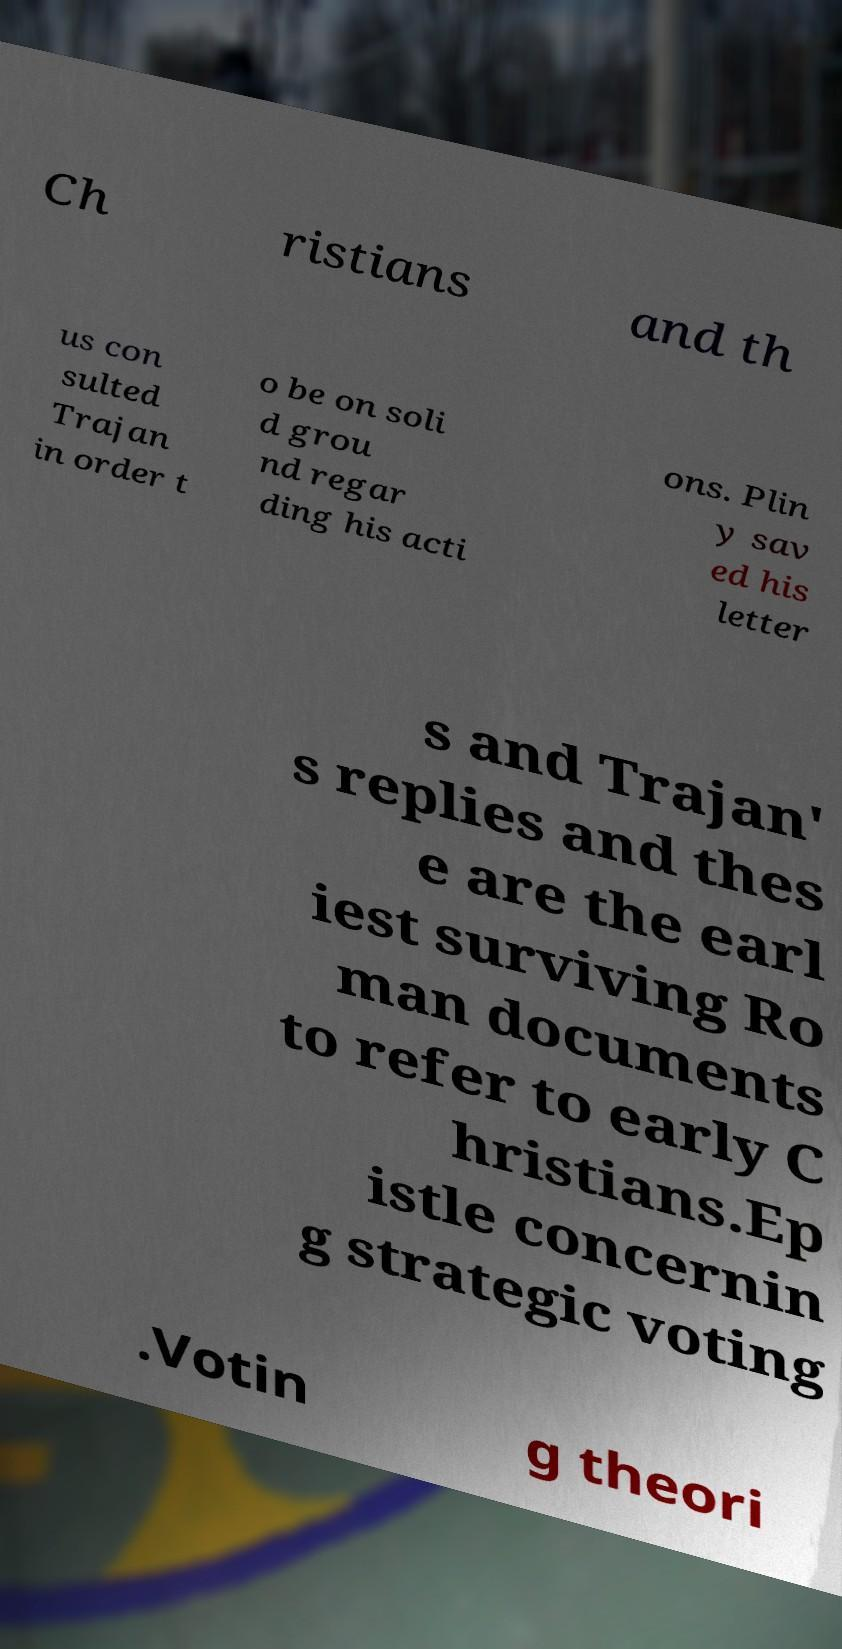Could you assist in decoding the text presented in this image and type it out clearly? Ch ristians and th us con sulted Trajan in order t o be on soli d grou nd regar ding his acti ons. Plin y sav ed his letter s and Trajan' s replies and thes e are the earl iest surviving Ro man documents to refer to early C hristians.Ep istle concernin g strategic voting .Votin g theori 